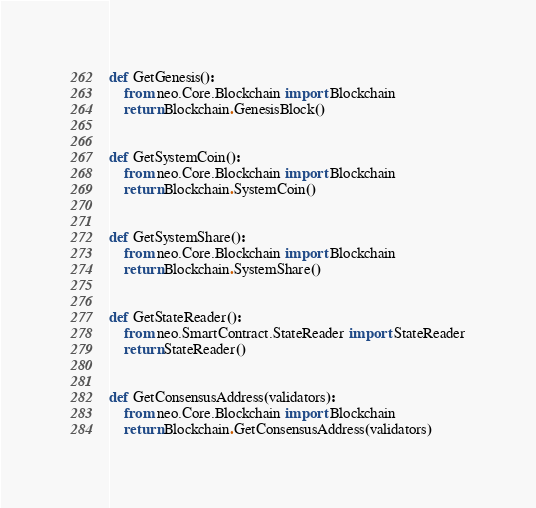Convert code to text. <code><loc_0><loc_0><loc_500><loc_500><_Python_>def GetGenesis():
    from neo.Core.Blockchain import Blockchain
    return Blockchain.GenesisBlock()


def GetSystemCoin():
    from neo.Core.Blockchain import Blockchain
    return Blockchain.SystemCoin()


def GetSystemShare():
    from neo.Core.Blockchain import Blockchain
    return Blockchain.SystemShare()


def GetStateReader():
    from neo.SmartContract.StateReader import StateReader
    return StateReader()


def GetConsensusAddress(validators):
    from neo.Core.Blockchain import Blockchain
    return Blockchain.GetConsensusAddress(validators)
</code> 